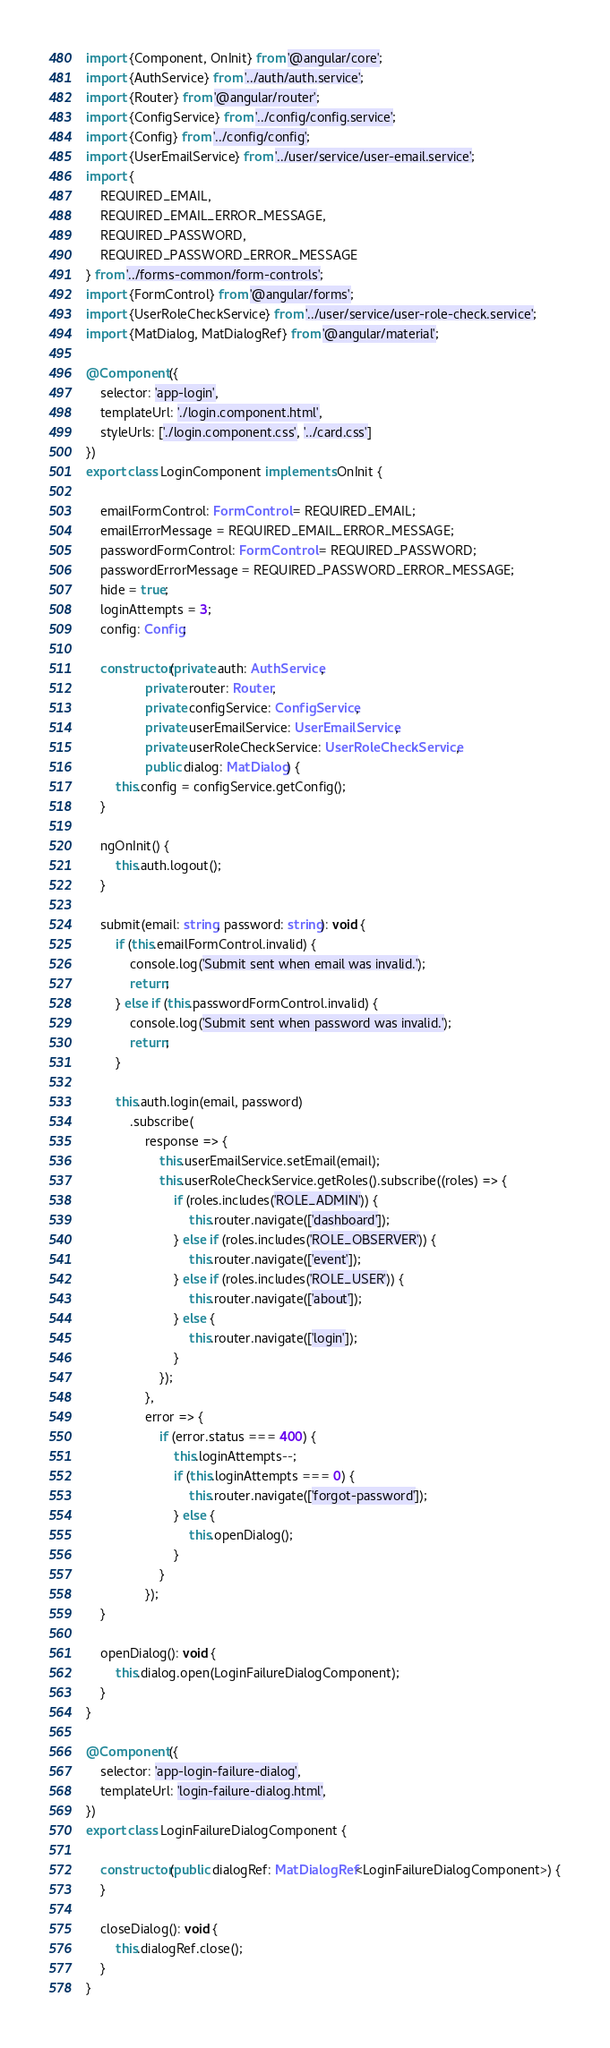Convert code to text. <code><loc_0><loc_0><loc_500><loc_500><_TypeScript_>import {Component, OnInit} from '@angular/core';
import {AuthService} from '../auth/auth.service';
import {Router} from '@angular/router';
import {ConfigService} from '../config/config.service';
import {Config} from '../config/config';
import {UserEmailService} from '../user/service/user-email.service';
import {
    REQUIRED_EMAIL,
    REQUIRED_EMAIL_ERROR_MESSAGE,
    REQUIRED_PASSWORD,
    REQUIRED_PASSWORD_ERROR_MESSAGE
} from '../forms-common/form-controls';
import {FormControl} from '@angular/forms';
import {UserRoleCheckService} from '../user/service/user-role-check.service';
import {MatDialog, MatDialogRef} from '@angular/material';

@Component({
    selector: 'app-login',
    templateUrl: './login.component.html',
    styleUrls: ['./login.component.css', '../card.css']
})
export class LoginComponent implements OnInit {

    emailFormControl: FormControl = REQUIRED_EMAIL;
    emailErrorMessage = REQUIRED_EMAIL_ERROR_MESSAGE;
    passwordFormControl: FormControl = REQUIRED_PASSWORD;
    passwordErrorMessage = REQUIRED_PASSWORD_ERROR_MESSAGE;
    hide = true;
    loginAttempts = 3;
    config: Config;

    constructor(private auth: AuthService,
                private router: Router,
                private configService: ConfigService,
                private userEmailService: UserEmailService,
                private userRoleCheckService: UserRoleCheckService,
                public dialog: MatDialog) {
        this.config = configService.getConfig();
    }

    ngOnInit() {
        this.auth.logout();
    }

    submit(email: string, password: string): void {
        if (this.emailFormControl.invalid) {
            console.log('Submit sent when email was invalid.');
            return;
        } else if (this.passwordFormControl.invalid) {
            console.log('Submit sent when password was invalid.');
            return;
        }

        this.auth.login(email, password)
            .subscribe(
                response => {
                    this.userEmailService.setEmail(email);
                    this.userRoleCheckService.getRoles().subscribe((roles) => {
                        if (roles.includes('ROLE_ADMIN')) {
                            this.router.navigate(['dashboard']);
                        } else if (roles.includes('ROLE_OBSERVER')) {
                            this.router.navigate(['event']);
                        } else if (roles.includes('ROLE_USER')) {
                            this.router.navigate(['about']);
                        } else {
                            this.router.navigate(['login']);
                        }
                    });
                },
                error => {
                    if (error.status === 400) {
                        this.loginAttempts--;
                        if (this.loginAttempts === 0) {
                            this.router.navigate(['forgot-password']);
                        } else {
                            this.openDialog();
                        }
                    }
                });
    }

    openDialog(): void {
        this.dialog.open(LoginFailureDialogComponent);
    }
}

@Component({
    selector: 'app-login-failure-dialog',
    templateUrl: 'login-failure-dialog.html',
})
export class LoginFailureDialogComponent {

    constructor(public dialogRef: MatDialogRef<LoginFailureDialogComponent>) {
    }

    closeDialog(): void {
        this.dialogRef.close();
    }
}

</code> 